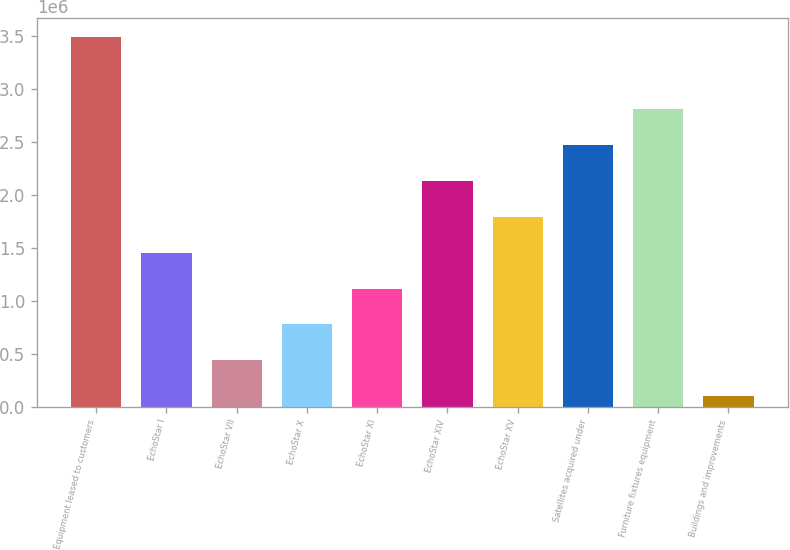Convert chart to OTSL. <chart><loc_0><loc_0><loc_500><loc_500><bar_chart><fcel>Equipment leased to customers<fcel>EchoStar I<fcel>EchoStar VII<fcel>EchoStar X<fcel>EchoStar XI<fcel>EchoStar XIV<fcel>EchoStar XV<fcel>Satellites acquired under<fcel>Furniture fixtures equipment<fcel>Buildings and improvements<nl><fcel>3.49615e+06<fcel>1.45807e+06<fcel>439027<fcel>778708<fcel>1.11839e+06<fcel>2.13743e+06<fcel>1.79775e+06<fcel>2.47711e+06<fcel>2.81679e+06<fcel>99346<nl></chart> 